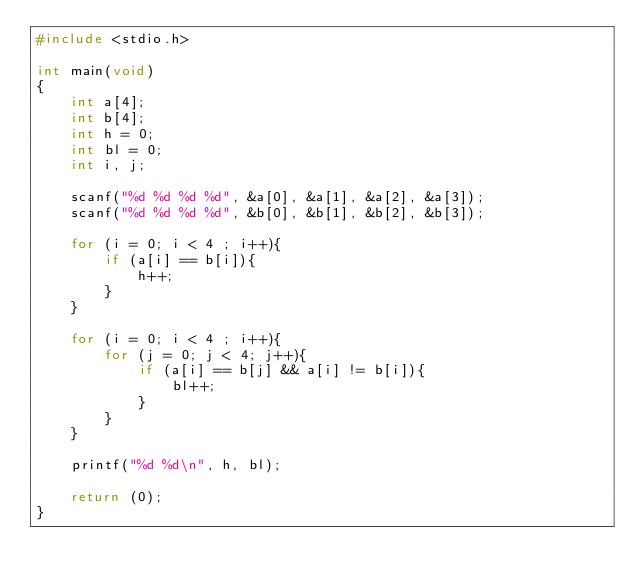Convert code to text. <code><loc_0><loc_0><loc_500><loc_500><_C_>#include <stdio.h>

int main(void)
{
	int a[4];
	int b[4];
	int h = 0;
	int bl = 0;
	int i, j;
	
	scanf("%d %d %d %d", &a[0], &a[1], &a[2], &a[3]);
	scanf("%d %d %d %d", &b[0], &b[1], &b[2], &b[3]);
	
	for (i = 0; i < 4 ; i++){
		if (a[i] == b[i]){
			h++;
		}
	}
	
	for (i = 0; i < 4 ; i++){
		for (j = 0; j < 4; j++){
			if (a[i] == b[j] && a[i] != b[i]){
				bl++;
			}
		}
	}
	
	printf("%d %d\n", h, bl);
	
	return (0);
}
				</code> 